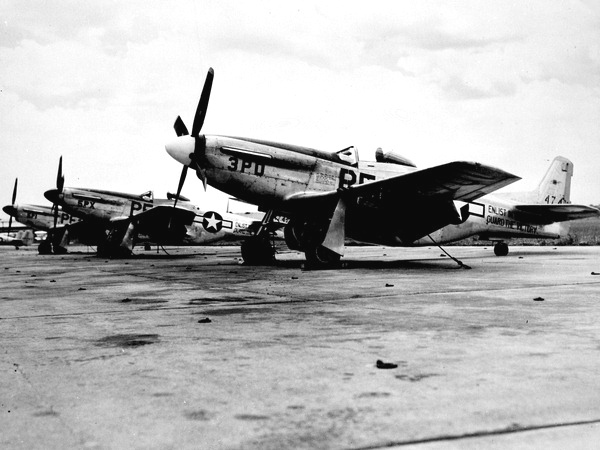Identify and read out the text in this image. 3PD 47 P P 